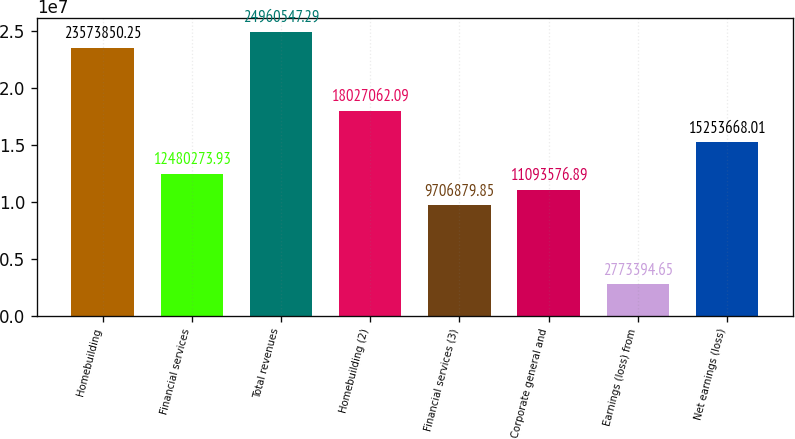Convert chart to OTSL. <chart><loc_0><loc_0><loc_500><loc_500><bar_chart><fcel>Homebuilding<fcel>Financial services<fcel>Total revenues<fcel>Homebuilding (2)<fcel>Financial services (3)<fcel>Corporate general and<fcel>Earnings (loss) from<fcel>Net earnings (loss)<nl><fcel>2.35739e+07<fcel>1.24803e+07<fcel>2.49605e+07<fcel>1.80271e+07<fcel>9.70688e+06<fcel>1.10936e+07<fcel>2.77339e+06<fcel>1.52537e+07<nl></chart> 